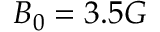Convert formula to latex. <formula><loc_0><loc_0><loc_500><loc_500>B _ { 0 } = 3 . 5 G</formula> 